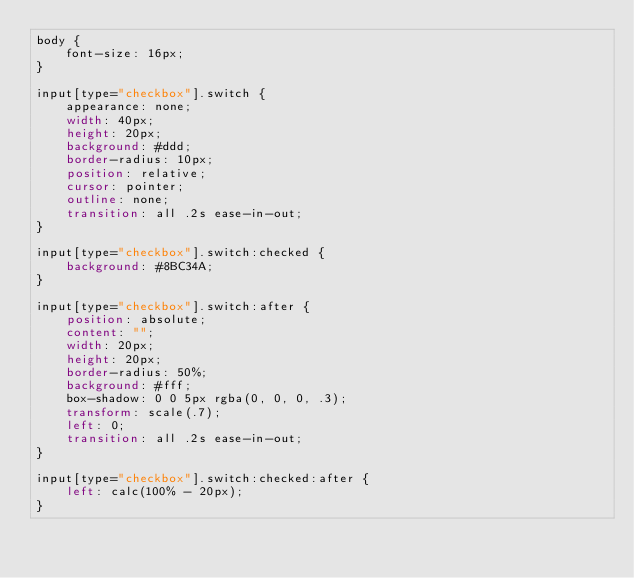Convert code to text. <code><loc_0><loc_0><loc_500><loc_500><_CSS_>body {
    font-size: 16px;
}

input[type="checkbox"].switch {
    appearance: none;
    width: 40px;
    height: 20px;
    background: #ddd;
    border-radius: 10px;
    position: relative;
    cursor: pointer;
    outline: none;
    transition: all .2s ease-in-out;
}

input[type="checkbox"].switch:checked {
    background: #8BC34A;
}

input[type="checkbox"].switch:after {
    position: absolute;
    content: "";
    width: 20px;
    height: 20px;
    border-radius: 50%;
    background: #fff;
    box-shadow: 0 0 5px rgba(0, 0, 0, .3);
    transform: scale(.7);
    left: 0;
    transition: all .2s ease-in-out;
}

input[type="checkbox"].switch:checked:after {
    left: calc(100% - 20px);
}</code> 